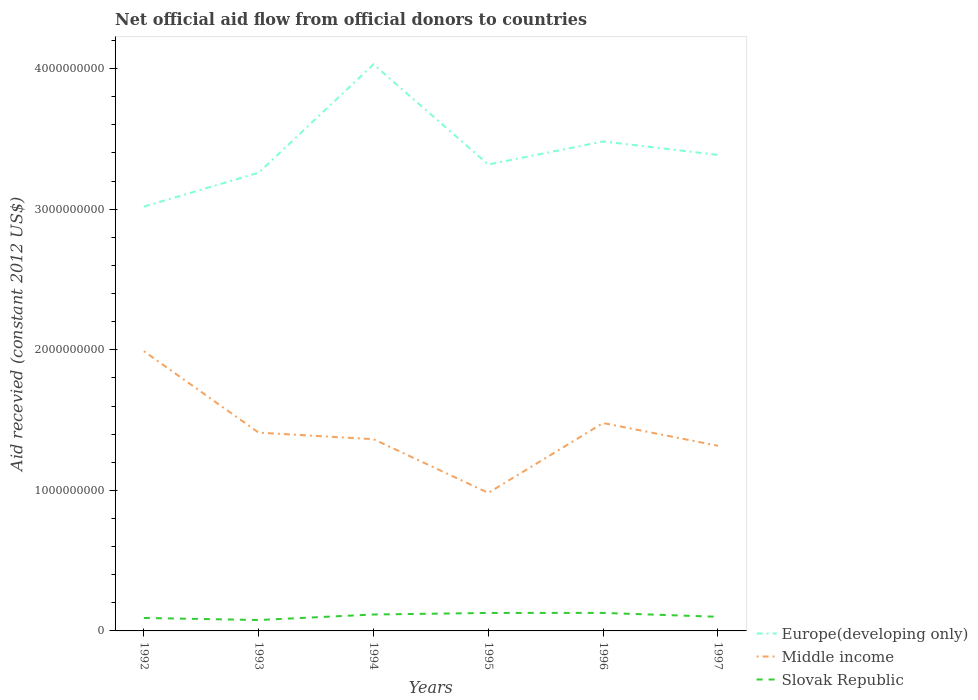How many different coloured lines are there?
Your answer should be very brief. 3. Does the line corresponding to Slovak Republic intersect with the line corresponding to Middle income?
Provide a succinct answer. No. Is the number of lines equal to the number of legend labels?
Make the answer very short. Yes. Across all years, what is the maximum total aid received in Europe(developing only)?
Your answer should be compact. 3.02e+09. In which year was the total aid received in Slovak Republic maximum?
Your response must be concise. 1993. What is the total total aid received in Europe(developing only) in the graph?
Provide a short and direct response. -2.22e+08. What is the difference between the highest and the second highest total aid received in Middle income?
Provide a short and direct response. 1.01e+09. Is the total aid received in Middle income strictly greater than the total aid received in Europe(developing only) over the years?
Offer a terse response. Yes. Does the graph contain any zero values?
Make the answer very short. No. How many legend labels are there?
Your answer should be very brief. 3. How are the legend labels stacked?
Your answer should be compact. Vertical. What is the title of the graph?
Offer a terse response. Net official aid flow from official donors to countries. Does "Thailand" appear as one of the legend labels in the graph?
Provide a short and direct response. No. What is the label or title of the X-axis?
Offer a very short reply. Years. What is the label or title of the Y-axis?
Your answer should be compact. Aid recevied (constant 2012 US$). What is the Aid recevied (constant 2012 US$) of Europe(developing only) in 1992?
Give a very brief answer. 3.02e+09. What is the Aid recevied (constant 2012 US$) in Middle income in 1992?
Provide a succinct answer. 1.99e+09. What is the Aid recevied (constant 2012 US$) in Slovak Republic in 1992?
Your response must be concise. 9.22e+07. What is the Aid recevied (constant 2012 US$) in Europe(developing only) in 1993?
Offer a very short reply. 3.26e+09. What is the Aid recevied (constant 2012 US$) of Middle income in 1993?
Keep it short and to the point. 1.41e+09. What is the Aid recevied (constant 2012 US$) in Slovak Republic in 1993?
Your response must be concise. 7.76e+07. What is the Aid recevied (constant 2012 US$) in Europe(developing only) in 1994?
Make the answer very short. 4.03e+09. What is the Aid recevied (constant 2012 US$) in Middle income in 1994?
Provide a short and direct response. 1.36e+09. What is the Aid recevied (constant 2012 US$) of Slovak Republic in 1994?
Keep it short and to the point. 1.17e+08. What is the Aid recevied (constant 2012 US$) of Europe(developing only) in 1995?
Ensure brevity in your answer.  3.32e+09. What is the Aid recevied (constant 2012 US$) in Middle income in 1995?
Your response must be concise. 9.82e+08. What is the Aid recevied (constant 2012 US$) in Slovak Republic in 1995?
Make the answer very short. 1.28e+08. What is the Aid recevied (constant 2012 US$) in Europe(developing only) in 1996?
Your answer should be very brief. 3.48e+09. What is the Aid recevied (constant 2012 US$) in Middle income in 1996?
Keep it short and to the point. 1.48e+09. What is the Aid recevied (constant 2012 US$) in Slovak Republic in 1996?
Your answer should be very brief. 1.28e+08. What is the Aid recevied (constant 2012 US$) in Europe(developing only) in 1997?
Provide a short and direct response. 3.39e+09. What is the Aid recevied (constant 2012 US$) of Middle income in 1997?
Provide a succinct answer. 1.32e+09. What is the Aid recevied (constant 2012 US$) of Slovak Republic in 1997?
Provide a succinct answer. 1.00e+08. Across all years, what is the maximum Aid recevied (constant 2012 US$) in Europe(developing only)?
Your response must be concise. 4.03e+09. Across all years, what is the maximum Aid recevied (constant 2012 US$) in Middle income?
Provide a succinct answer. 1.99e+09. Across all years, what is the maximum Aid recevied (constant 2012 US$) of Slovak Republic?
Keep it short and to the point. 1.28e+08. Across all years, what is the minimum Aid recevied (constant 2012 US$) of Europe(developing only)?
Your answer should be very brief. 3.02e+09. Across all years, what is the minimum Aid recevied (constant 2012 US$) in Middle income?
Provide a short and direct response. 9.82e+08. Across all years, what is the minimum Aid recevied (constant 2012 US$) of Slovak Republic?
Your answer should be very brief. 7.76e+07. What is the total Aid recevied (constant 2012 US$) in Europe(developing only) in the graph?
Provide a short and direct response. 2.05e+1. What is the total Aid recevied (constant 2012 US$) of Middle income in the graph?
Your answer should be compact. 8.54e+09. What is the total Aid recevied (constant 2012 US$) in Slovak Republic in the graph?
Give a very brief answer. 6.43e+08. What is the difference between the Aid recevied (constant 2012 US$) of Europe(developing only) in 1992 and that in 1993?
Give a very brief answer. -2.41e+08. What is the difference between the Aid recevied (constant 2012 US$) of Middle income in 1992 and that in 1993?
Make the answer very short. 5.79e+08. What is the difference between the Aid recevied (constant 2012 US$) of Slovak Republic in 1992 and that in 1993?
Give a very brief answer. 1.47e+07. What is the difference between the Aid recevied (constant 2012 US$) of Europe(developing only) in 1992 and that in 1994?
Keep it short and to the point. -1.01e+09. What is the difference between the Aid recevied (constant 2012 US$) of Middle income in 1992 and that in 1994?
Your answer should be compact. 6.26e+08. What is the difference between the Aid recevied (constant 2012 US$) in Slovak Republic in 1992 and that in 1994?
Keep it short and to the point. -2.45e+07. What is the difference between the Aid recevied (constant 2012 US$) of Europe(developing only) in 1992 and that in 1995?
Your answer should be compact. -2.99e+08. What is the difference between the Aid recevied (constant 2012 US$) of Middle income in 1992 and that in 1995?
Ensure brevity in your answer.  1.01e+09. What is the difference between the Aid recevied (constant 2012 US$) in Slovak Republic in 1992 and that in 1995?
Your response must be concise. -3.57e+07. What is the difference between the Aid recevied (constant 2012 US$) in Europe(developing only) in 1992 and that in 1996?
Offer a very short reply. -4.64e+08. What is the difference between the Aid recevied (constant 2012 US$) of Middle income in 1992 and that in 1996?
Keep it short and to the point. 5.11e+08. What is the difference between the Aid recevied (constant 2012 US$) in Slovak Republic in 1992 and that in 1996?
Your answer should be very brief. -3.59e+07. What is the difference between the Aid recevied (constant 2012 US$) in Europe(developing only) in 1992 and that in 1997?
Offer a terse response. -3.68e+08. What is the difference between the Aid recevied (constant 2012 US$) of Middle income in 1992 and that in 1997?
Provide a succinct answer. 6.73e+08. What is the difference between the Aid recevied (constant 2012 US$) in Slovak Republic in 1992 and that in 1997?
Your response must be concise. -8.17e+06. What is the difference between the Aid recevied (constant 2012 US$) in Europe(developing only) in 1993 and that in 1994?
Your answer should be compact. -7.71e+08. What is the difference between the Aid recevied (constant 2012 US$) of Middle income in 1993 and that in 1994?
Your answer should be compact. 4.66e+07. What is the difference between the Aid recevied (constant 2012 US$) of Slovak Republic in 1993 and that in 1994?
Make the answer very short. -3.92e+07. What is the difference between the Aid recevied (constant 2012 US$) in Europe(developing only) in 1993 and that in 1995?
Your response must be concise. -5.79e+07. What is the difference between the Aid recevied (constant 2012 US$) in Middle income in 1993 and that in 1995?
Your answer should be very brief. 4.29e+08. What is the difference between the Aid recevied (constant 2012 US$) in Slovak Republic in 1993 and that in 1995?
Make the answer very short. -5.04e+07. What is the difference between the Aid recevied (constant 2012 US$) in Europe(developing only) in 1993 and that in 1996?
Offer a terse response. -2.22e+08. What is the difference between the Aid recevied (constant 2012 US$) in Middle income in 1993 and that in 1996?
Your response must be concise. -6.84e+07. What is the difference between the Aid recevied (constant 2012 US$) in Slovak Republic in 1993 and that in 1996?
Give a very brief answer. -5.06e+07. What is the difference between the Aid recevied (constant 2012 US$) in Europe(developing only) in 1993 and that in 1997?
Offer a terse response. -1.26e+08. What is the difference between the Aid recevied (constant 2012 US$) of Middle income in 1993 and that in 1997?
Your response must be concise. 9.34e+07. What is the difference between the Aid recevied (constant 2012 US$) of Slovak Republic in 1993 and that in 1997?
Keep it short and to the point. -2.28e+07. What is the difference between the Aid recevied (constant 2012 US$) of Europe(developing only) in 1994 and that in 1995?
Your answer should be compact. 7.13e+08. What is the difference between the Aid recevied (constant 2012 US$) of Middle income in 1994 and that in 1995?
Your answer should be very brief. 3.82e+08. What is the difference between the Aid recevied (constant 2012 US$) of Slovak Republic in 1994 and that in 1995?
Keep it short and to the point. -1.12e+07. What is the difference between the Aid recevied (constant 2012 US$) in Europe(developing only) in 1994 and that in 1996?
Your response must be concise. 5.48e+08. What is the difference between the Aid recevied (constant 2012 US$) in Middle income in 1994 and that in 1996?
Your response must be concise. -1.15e+08. What is the difference between the Aid recevied (constant 2012 US$) of Slovak Republic in 1994 and that in 1996?
Offer a terse response. -1.14e+07. What is the difference between the Aid recevied (constant 2012 US$) of Europe(developing only) in 1994 and that in 1997?
Offer a terse response. 6.44e+08. What is the difference between the Aid recevied (constant 2012 US$) of Middle income in 1994 and that in 1997?
Provide a succinct answer. 4.68e+07. What is the difference between the Aid recevied (constant 2012 US$) in Slovak Republic in 1994 and that in 1997?
Your answer should be very brief. 1.64e+07. What is the difference between the Aid recevied (constant 2012 US$) of Europe(developing only) in 1995 and that in 1996?
Ensure brevity in your answer.  -1.64e+08. What is the difference between the Aid recevied (constant 2012 US$) of Middle income in 1995 and that in 1996?
Ensure brevity in your answer.  -4.97e+08. What is the difference between the Aid recevied (constant 2012 US$) in Europe(developing only) in 1995 and that in 1997?
Offer a very short reply. -6.84e+07. What is the difference between the Aid recevied (constant 2012 US$) of Middle income in 1995 and that in 1997?
Your response must be concise. -3.35e+08. What is the difference between the Aid recevied (constant 2012 US$) in Slovak Republic in 1995 and that in 1997?
Provide a succinct answer. 2.75e+07. What is the difference between the Aid recevied (constant 2012 US$) of Europe(developing only) in 1996 and that in 1997?
Give a very brief answer. 9.58e+07. What is the difference between the Aid recevied (constant 2012 US$) in Middle income in 1996 and that in 1997?
Your answer should be very brief. 1.62e+08. What is the difference between the Aid recevied (constant 2012 US$) in Slovak Republic in 1996 and that in 1997?
Offer a very short reply. 2.77e+07. What is the difference between the Aid recevied (constant 2012 US$) in Europe(developing only) in 1992 and the Aid recevied (constant 2012 US$) in Middle income in 1993?
Your answer should be very brief. 1.61e+09. What is the difference between the Aid recevied (constant 2012 US$) of Europe(developing only) in 1992 and the Aid recevied (constant 2012 US$) of Slovak Republic in 1993?
Make the answer very short. 2.94e+09. What is the difference between the Aid recevied (constant 2012 US$) of Middle income in 1992 and the Aid recevied (constant 2012 US$) of Slovak Republic in 1993?
Make the answer very short. 1.91e+09. What is the difference between the Aid recevied (constant 2012 US$) in Europe(developing only) in 1992 and the Aid recevied (constant 2012 US$) in Middle income in 1994?
Your answer should be very brief. 1.65e+09. What is the difference between the Aid recevied (constant 2012 US$) of Europe(developing only) in 1992 and the Aid recevied (constant 2012 US$) of Slovak Republic in 1994?
Make the answer very short. 2.90e+09. What is the difference between the Aid recevied (constant 2012 US$) in Middle income in 1992 and the Aid recevied (constant 2012 US$) in Slovak Republic in 1994?
Provide a succinct answer. 1.87e+09. What is the difference between the Aid recevied (constant 2012 US$) of Europe(developing only) in 1992 and the Aid recevied (constant 2012 US$) of Middle income in 1995?
Your answer should be compact. 2.04e+09. What is the difference between the Aid recevied (constant 2012 US$) in Europe(developing only) in 1992 and the Aid recevied (constant 2012 US$) in Slovak Republic in 1995?
Offer a very short reply. 2.89e+09. What is the difference between the Aid recevied (constant 2012 US$) of Middle income in 1992 and the Aid recevied (constant 2012 US$) of Slovak Republic in 1995?
Your answer should be compact. 1.86e+09. What is the difference between the Aid recevied (constant 2012 US$) in Europe(developing only) in 1992 and the Aid recevied (constant 2012 US$) in Middle income in 1996?
Your response must be concise. 1.54e+09. What is the difference between the Aid recevied (constant 2012 US$) in Europe(developing only) in 1992 and the Aid recevied (constant 2012 US$) in Slovak Republic in 1996?
Provide a short and direct response. 2.89e+09. What is the difference between the Aid recevied (constant 2012 US$) in Middle income in 1992 and the Aid recevied (constant 2012 US$) in Slovak Republic in 1996?
Provide a short and direct response. 1.86e+09. What is the difference between the Aid recevied (constant 2012 US$) of Europe(developing only) in 1992 and the Aid recevied (constant 2012 US$) of Middle income in 1997?
Make the answer very short. 1.70e+09. What is the difference between the Aid recevied (constant 2012 US$) of Europe(developing only) in 1992 and the Aid recevied (constant 2012 US$) of Slovak Republic in 1997?
Give a very brief answer. 2.92e+09. What is the difference between the Aid recevied (constant 2012 US$) of Middle income in 1992 and the Aid recevied (constant 2012 US$) of Slovak Republic in 1997?
Provide a succinct answer. 1.89e+09. What is the difference between the Aid recevied (constant 2012 US$) of Europe(developing only) in 1993 and the Aid recevied (constant 2012 US$) of Middle income in 1994?
Your answer should be very brief. 1.90e+09. What is the difference between the Aid recevied (constant 2012 US$) in Europe(developing only) in 1993 and the Aid recevied (constant 2012 US$) in Slovak Republic in 1994?
Keep it short and to the point. 3.14e+09. What is the difference between the Aid recevied (constant 2012 US$) of Middle income in 1993 and the Aid recevied (constant 2012 US$) of Slovak Republic in 1994?
Offer a very short reply. 1.29e+09. What is the difference between the Aid recevied (constant 2012 US$) in Europe(developing only) in 1993 and the Aid recevied (constant 2012 US$) in Middle income in 1995?
Give a very brief answer. 2.28e+09. What is the difference between the Aid recevied (constant 2012 US$) of Europe(developing only) in 1993 and the Aid recevied (constant 2012 US$) of Slovak Republic in 1995?
Give a very brief answer. 3.13e+09. What is the difference between the Aid recevied (constant 2012 US$) of Middle income in 1993 and the Aid recevied (constant 2012 US$) of Slovak Republic in 1995?
Keep it short and to the point. 1.28e+09. What is the difference between the Aid recevied (constant 2012 US$) in Europe(developing only) in 1993 and the Aid recevied (constant 2012 US$) in Middle income in 1996?
Give a very brief answer. 1.78e+09. What is the difference between the Aid recevied (constant 2012 US$) of Europe(developing only) in 1993 and the Aid recevied (constant 2012 US$) of Slovak Republic in 1996?
Ensure brevity in your answer.  3.13e+09. What is the difference between the Aid recevied (constant 2012 US$) of Middle income in 1993 and the Aid recevied (constant 2012 US$) of Slovak Republic in 1996?
Provide a succinct answer. 1.28e+09. What is the difference between the Aid recevied (constant 2012 US$) of Europe(developing only) in 1993 and the Aid recevied (constant 2012 US$) of Middle income in 1997?
Provide a succinct answer. 1.94e+09. What is the difference between the Aid recevied (constant 2012 US$) in Europe(developing only) in 1993 and the Aid recevied (constant 2012 US$) in Slovak Republic in 1997?
Your answer should be very brief. 3.16e+09. What is the difference between the Aid recevied (constant 2012 US$) in Middle income in 1993 and the Aid recevied (constant 2012 US$) in Slovak Republic in 1997?
Keep it short and to the point. 1.31e+09. What is the difference between the Aid recevied (constant 2012 US$) in Europe(developing only) in 1994 and the Aid recevied (constant 2012 US$) in Middle income in 1995?
Make the answer very short. 3.05e+09. What is the difference between the Aid recevied (constant 2012 US$) in Europe(developing only) in 1994 and the Aid recevied (constant 2012 US$) in Slovak Republic in 1995?
Provide a short and direct response. 3.90e+09. What is the difference between the Aid recevied (constant 2012 US$) of Middle income in 1994 and the Aid recevied (constant 2012 US$) of Slovak Republic in 1995?
Your answer should be very brief. 1.24e+09. What is the difference between the Aid recevied (constant 2012 US$) of Europe(developing only) in 1994 and the Aid recevied (constant 2012 US$) of Middle income in 1996?
Ensure brevity in your answer.  2.55e+09. What is the difference between the Aid recevied (constant 2012 US$) in Europe(developing only) in 1994 and the Aid recevied (constant 2012 US$) in Slovak Republic in 1996?
Your answer should be compact. 3.90e+09. What is the difference between the Aid recevied (constant 2012 US$) in Middle income in 1994 and the Aid recevied (constant 2012 US$) in Slovak Republic in 1996?
Give a very brief answer. 1.24e+09. What is the difference between the Aid recevied (constant 2012 US$) of Europe(developing only) in 1994 and the Aid recevied (constant 2012 US$) of Middle income in 1997?
Make the answer very short. 2.71e+09. What is the difference between the Aid recevied (constant 2012 US$) of Europe(developing only) in 1994 and the Aid recevied (constant 2012 US$) of Slovak Republic in 1997?
Offer a terse response. 3.93e+09. What is the difference between the Aid recevied (constant 2012 US$) in Middle income in 1994 and the Aid recevied (constant 2012 US$) in Slovak Republic in 1997?
Give a very brief answer. 1.26e+09. What is the difference between the Aid recevied (constant 2012 US$) in Europe(developing only) in 1995 and the Aid recevied (constant 2012 US$) in Middle income in 1996?
Your answer should be compact. 1.84e+09. What is the difference between the Aid recevied (constant 2012 US$) in Europe(developing only) in 1995 and the Aid recevied (constant 2012 US$) in Slovak Republic in 1996?
Keep it short and to the point. 3.19e+09. What is the difference between the Aid recevied (constant 2012 US$) in Middle income in 1995 and the Aid recevied (constant 2012 US$) in Slovak Republic in 1996?
Your response must be concise. 8.54e+08. What is the difference between the Aid recevied (constant 2012 US$) in Europe(developing only) in 1995 and the Aid recevied (constant 2012 US$) in Middle income in 1997?
Ensure brevity in your answer.  2.00e+09. What is the difference between the Aid recevied (constant 2012 US$) of Europe(developing only) in 1995 and the Aid recevied (constant 2012 US$) of Slovak Republic in 1997?
Your answer should be very brief. 3.22e+09. What is the difference between the Aid recevied (constant 2012 US$) of Middle income in 1995 and the Aid recevied (constant 2012 US$) of Slovak Republic in 1997?
Offer a very short reply. 8.82e+08. What is the difference between the Aid recevied (constant 2012 US$) in Europe(developing only) in 1996 and the Aid recevied (constant 2012 US$) in Middle income in 1997?
Provide a succinct answer. 2.16e+09. What is the difference between the Aid recevied (constant 2012 US$) in Europe(developing only) in 1996 and the Aid recevied (constant 2012 US$) in Slovak Republic in 1997?
Make the answer very short. 3.38e+09. What is the difference between the Aid recevied (constant 2012 US$) of Middle income in 1996 and the Aid recevied (constant 2012 US$) of Slovak Republic in 1997?
Offer a terse response. 1.38e+09. What is the average Aid recevied (constant 2012 US$) in Europe(developing only) per year?
Ensure brevity in your answer.  3.42e+09. What is the average Aid recevied (constant 2012 US$) of Middle income per year?
Offer a terse response. 1.42e+09. What is the average Aid recevied (constant 2012 US$) in Slovak Republic per year?
Give a very brief answer. 1.07e+08. In the year 1992, what is the difference between the Aid recevied (constant 2012 US$) in Europe(developing only) and Aid recevied (constant 2012 US$) in Middle income?
Your response must be concise. 1.03e+09. In the year 1992, what is the difference between the Aid recevied (constant 2012 US$) of Europe(developing only) and Aid recevied (constant 2012 US$) of Slovak Republic?
Give a very brief answer. 2.93e+09. In the year 1992, what is the difference between the Aid recevied (constant 2012 US$) of Middle income and Aid recevied (constant 2012 US$) of Slovak Republic?
Give a very brief answer. 1.90e+09. In the year 1993, what is the difference between the Aid recevied (constant 2012 US$) of Europe(developing only) and Aid recevied (constant 2012 US$) of Middle income?
Make the answer very short. 1.85e+09. In the year 1993, what is the difference between the Aid recevied (constant 2012 US$) of Europe(developing only) and Aid recevied (constant 2012 US$) of Slovak Republic?
Offer a very short reply. 3.18e+09. In the year 1993, what is the difference between the Aid recevied (constant 2012 US$) of Middle income and Aid recevied (constant 2012 US$) of Slovak Republic?
Your response must be concise. 1.33e+09. In the year 1994, what is the difference between the Aid recevied (constant 2012 US$) in Europe(developing only) and Aid recevied (constant 2012 US$) in Middle income?
Offer a very short reply. 2.67e+09. In the year 1994, what is the difference between the Aid recevied (constant 2012 US$) in Europe(developing only) and Aid recevied (constant 2012 US$) in Slovak Republic?
Give a very brief answer. 3.91e+09. In the year 1994, what is the difference between the Aid recevied (constant 2012 US$) in Middle income and Aid recevied (constant 2012 US$) in Slovak Republic?
Offer a terse response. 1.25e+09. In the year 1995, what is the difference between the Aid recevied (constant 2012 US$) in Europe(developing only) and Aid recevied (constant 2012 US$) in Middle income?
Your answer should be compact. 2.34e+09. In the year 1995, what is the difference between the Aid recevied (constant 2012 US$) in Europe(developing only) and Aid recevied (constant 2012 US$) in Slovak Republic?
Keep it short and to the point. 3.19e+09. In the year 1995, what is the difference between the Aid recevied (constant 2012 US$) in Middle income and Aid recevied (constant 2012 US$) in Slovak Republic?
Your answer should be compact. 8.54e+08. In the year 1996, what is the difference between the Aid recevied (constant 2012 US$) of Europe(developing only) and Aid recevied (constant 2012 US$) of Middle income?
Provide a succinct answer. 2.00e+09. In the year 1996, what is the difference between the Aid recevied (constant 2012 US$) of Europe(developing only) and Aid recevied (constant 2012 US$) of Slovak Republic?
Offer a terse response. 3.35e+09. In the year 1996, what is the difference between the Aid recevied (constant 2012 US$) of Middle income and Aid recevied (constant 2012 US$) of Slovak Republic?
Offer a very short reply. 1.35e+09. In the year 1997, what is the difference between the Aid recevied (constant 2012 US$) in Europe(developing only) and Aid recevied (constant 2012 US$) in Middle income?
Provide a short and direct response. 2.07e+09. In the year 1997, what is the difference between the Aid recevied (constant 2012 US$) in Europe(developing only) and Aid recevied (constant 2012 US$) in Slovak Republic?
Provide a succinct answer. 3.29e+09. In the year 1997, what is the difference between the Aid recevied (constant 2012 US$) in Middle income and Aid recevied (constant 2012 US$) in Slovak Republic?
Your answer should be compact. 1.22e+09. What is the ratio of the Aid recevied (constant 2012 US$) of Europe(developing only) in 1992 to that in 1993?
Provide a short and direct response. 0.93. What is the ratio of the Aid recevied (constant 2012 US$) of Middle income in 1992 to that in 1993?
Provide a succinct answer. 1.41. What is the ratio of the Aid recevied (constant 2012 US$) of Slovak Republic in 1992 to that in 1993?
Provide a short and direct response. 1.19. What is the ratio of the Aid recevied (constant 2012 US$) of Europe(developing only) in 1992 to that in 1994?
Give a very brief answer. 0.75. What is the ratio of the Aid recevied (constant 2012 US$) in Middle income in 1992 to that in 1994?
Offer a very short reply. 1.46. What is the ratio of the Aid recevied (constant 2012 US$) of Slovak Republic in 1992 to that in 1994?
Ensure brevity in your answer.  0.79. What is the ratio of the Aid recevied (constant 2012 US$) in Europe(developing only) in 1992 to that in 1995?
Provide a short and direct response. 0.91. What is the ratio of the Aid recevied (constant 2012 US$) of Middle income in 1992 to that in 1995?
Your answer should be very brief. 2.03. What is the ratio of the Aid recevied (constant 2012 US$) of Slovak Republic in 1992 to that in 1995?
Make the answer very short. 0.72. What is the ratio of the Aid recevied (constant 2012 US$) of Europe(developing only) in 1992 to that in 1996?
Offer a terse response. 0.87. What is the ratio of the Aid recevied (constant 2012 US$) in Middle income in 1992 to that in 1996?
Keep it short and to the point. 1.35. What is the ratio of the Aid recevied (constant 2012 US$) of Slovak Republic in 1992 to that in 1996?
Your answer should be very brief. 0.72. What is the ratio of the Aid recevied (constant 2012 US$) of Europe(developing only) in 1992 to that in 1997?
Your answer should be compact. 0.89. What is the ratio of the Aid recevied (constant 2012 US$) in Middle income in 1992 to that in 1997?
Provide a short and direct response. 1.51. What is the ratio of the Aid recevied (constant 2012 US$) in Slovak Republic in 1992 to that in 1997?
Your response must be concise. 0.92. What is the ratio of the Aid recevied (constant 2012 US$) of Europe(developing only) in 1993 to that in 1994?
Offer a very short reply. 0.81. What is the ratio of the Aid recevied (constant 2012 US$) of Middle income in 1993 to that in 1994?
Give a very brief answer. 1.03. What is the ratio of the Aid recevied (constant 2012 US$) in Slovak Republic in 1993 to that in 1994?
Keep it short and to the point. 0.66. What is the ratio of the Aid recevied (constant 2012 US$) of Europe(developing only) in 1993 to that in 1995?
Your response must be concise. 0.98. What is the ratio of the Aid recevied (constant 2012 US$) in Middle income in 1993 to that in 1995?
Keep it short and to the point. 1.44. What is the ratio of the Aid recevied (constant 2012 US$) in Slovak Republic in 1993 to that in 1995?
Your answer should be compact. 0.61. What is the ratio of the Aid recevied (constant 2012 US$) of Europe(developing only) in 1993 to that in 1996?
Ensure brevity in your answer.  0.94. What is the ratio of the Aid recevied (constant 2012 US$) in Middle income in 1993 to that in 1996?
Your response must be concise. 0.95. What is the ratio of the Aid recevied (constant 2012 US$) in Slovak Republic in 1993 to that in 1996?
Ensure brevity in your answer.  0.61. What is the ratio of the Aid recevied (constant 2012 US$) of Europe(developing only) in 1993 to that in 1997?
Give a very brief answer. 0.96. What is the ratio of the Aid recevied (constant 2012 US$) of Middle income in 1993 to that in 1997?
Keep it short and to the point. 1.07. What is the ratio of the Aid recevied (constant 2012 US$) of Slovak Republic in 1993 to that in 1997?
Give a very brief answer. 0.77. What is the ratio of the Aid recevied (constant 2012 US$) in Europe(developing only) in 1994 to that in 1995?
Make the answer very short. 1.21. What is the ratio of the Aid recevied (constant 2012 US$) in Middle income in 1994 to that in 1995?
Provide a succinct answer. 1.39. What is the ratio of the Aid recevied (constant 2012 US$) of Slovak Republic in 1994 to that in 1995?
Your answer should be compact. 0.91. What is the ratio of the Aid recevied (constant 2012 US$) of Europe(developing only) in 1994 to that in 1996?
Keep it short and to the point. 1.16. What is the ratio of the Aid recevied (constant 2012 US$) in Middle income in 1994 to that in 1996?
Offer a terse response. 0.92. What is the ratio of the Aid recevied (constant 2012 US$) of Slovak Republic in 1994 to that in 1996?
Give a very brief answer. 0.91. What is the ratio of the Aid recevied (constant 2012 US$) of Europe(developing only) in 1994 to that in 1997?
Keep it short and to the point. 1.19. What is the ratio of the Aid recevied (constant 2012 US$) in Middle income in 1994 to that in 1997?
Provide a succinct answer. 1.04. What is the ratio of the Aid recevied (constant 2012 US$) in Slovak Republic in 1994 to that in 1997?
Your answer should be compact. 1.16. What is the ratio of the Aid recevied (constant 2012 US$) of Europe(developing only) in 1995 to that in 1996?
Your answer should be compact. 0.95. What is the ratio of the Aid recevied (constant 2012 US$) in Middle income in 1995 to that in 1996?
Give a very brief answer. 0.66. What is the ratio of the Aid recevied (constant 2012 US$) of Europe(developing only) in 1995 to that in 1997?
Offer a very short reply. 0.98. What is the ratio of the Aid recevied (constant 2012 US$) of Middle income in 1995 to that in 1997?
Offer a terse response. 0.75. What is the ratio of the Aid recevied (constant 2012 US$) in Slovak Republic in 1995 to that in 1997?
Your response must be concise. 1.27. What is the ratio of the Aid recevied (constant 2012 US$) of Europe(developing only) in 1996 to that in 1997?
Offer a very short reply. 1.03. What is the ratio of the Aid recevied (constant 2012 US$) of Middle income in 1996 to that in 1997?
Offer a terse response. 1.12. What is the ratio of the Aid recevied (constant 2012 US$) of Slovak Republic in 1996 to that in 1997?
Offer a very short reply. 1.28. What is the difference between the highest and the second highest Aid recevied (constant 2012 US$) of Europe(developing only)?
Provide a succinct answer. 5.48e+08. What is the difference between the highest and the second highest Aid recevied (constant 2012 US$) in Middle income?
Your response must be concise. 5.11e+08. What is the difference between the highest and the lowest Aid recevied (constant 2012 US$) of Europe(developing only)?
Keep it short and to the point. 1.01e+09. What is the difference between the highest and the lowest Aid recevied (constant 2012 US$) in Middle income?
Give a very brief answer. 1.01e+09. What is the difference between the highest and the lowest Aid recevied (constant 2012 US$) of Slovak Republic?
Your response must be concise. 5.06e+07. 